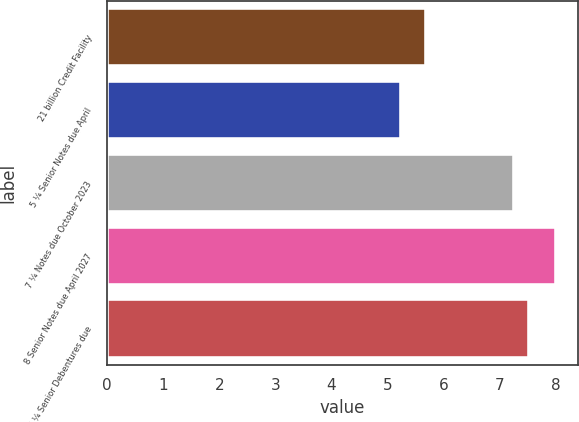<chart> <loc_0><loc_0><loc_500><loc_500><bar_chart><fcel>21 billion Credit Facility<fcel>5 ¼ Senior Notes due April<fcel>7 ¼ Notes due October 2023<fcel>8 Senior Notes due April 2027<fcel>7 ¼ Senior Debentures due<nl><fcel>5.69<fcel>5.25<fcel>7.25<fcel>8<fcel>7.53<nl></chart> 